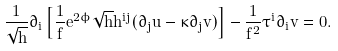<formula> <loc_0><loc_0><loc_500><loc_500>\frac { 1 } { \sqrt { h } } \partial _ { i } \left [ \frac { 1 } { f } e ^ { 2 \phi } \sqrt { h } h ^ { i j } ( \partial _ { j } u - \kappa \partial _ { j } v ) \right ] - \frac { 1 } { f ^ { 2 } } \tau ^ { i } \partial _ { i } v = 0 .</formula> 